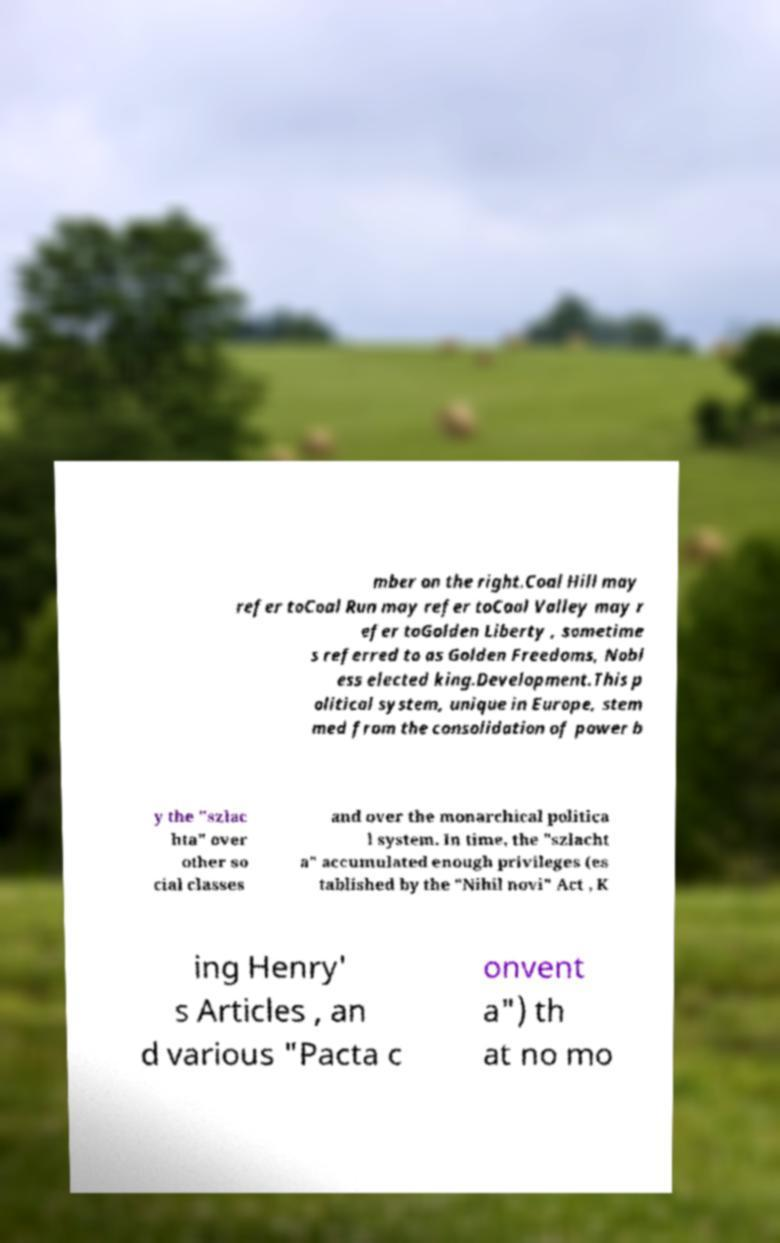Please identify and transcribe the text found in this image. mber on the right.Coal Hill may refer toCoal Run may refer toCoal Valley may r efer toGolden Liberty , sometime s referred to as Golden Freedoms, Nobl ess elected king.Development.This p olitical system, unique in Europe, stem med from the consolidation of power b y the "szlac hta" over other so cial classes and over the monarchical politica l system. In time, the "szlacht a" accumulated enough privileges (es tablished by the "Nihil novi" Act , K ing Henry' s Articles , an d various "Pacta c onvent a") th at no mo 